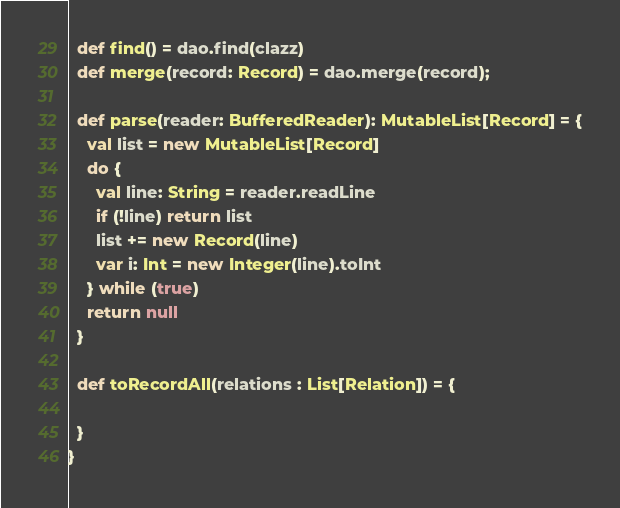Convert code to text. <code><loc_0><loc_0><loc_500><loc_500><_Scala_>  def find() = dao.find(clazz)
  def merge(record: Record) = dao.merge(record);

  def parse(reader: BufferedReader): MutableList[Record] = {
    val list = new MutableList[Record]
    do {
      val line: String = reader.readLine
      if (!line) return list
      list += new Record(line)
      var i: Int = new Integer(line).toInt
    } while (true)
    return null
  }
  
  def toRecordAll(relations : List[Relation]) = {
    
  }
}</code> 